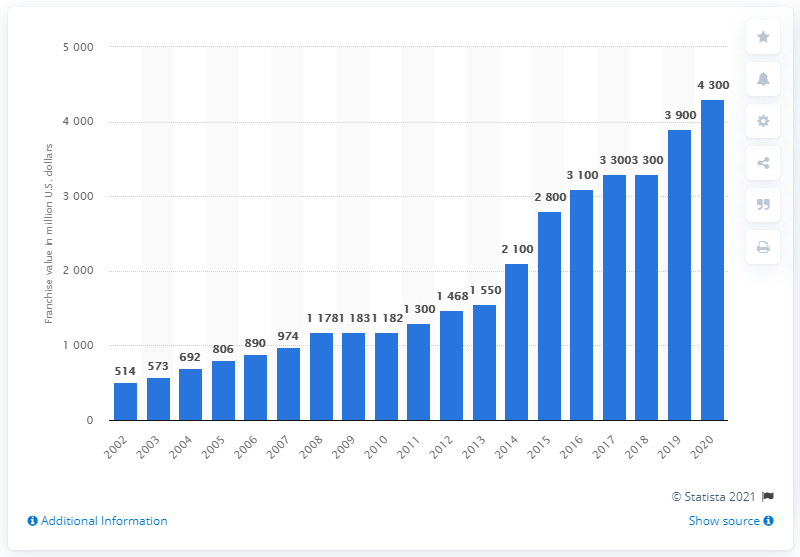Highlight a few significant elements in this photo. The franchise value of the New York Giants in 2020 was 4,300. 